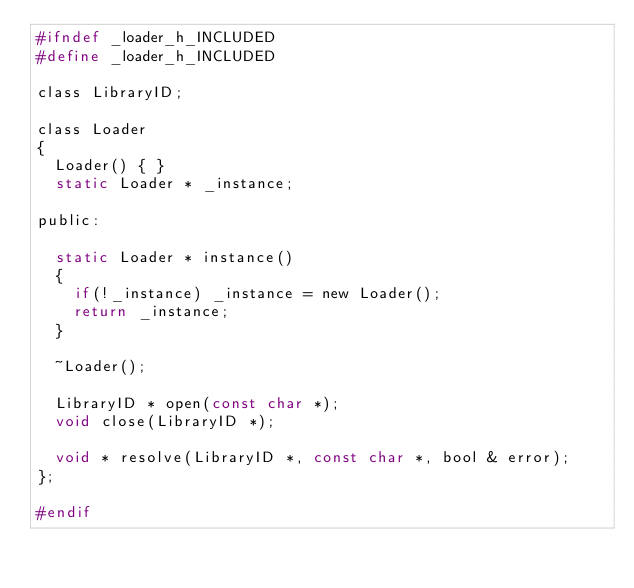Convert code to text. <code><loc_0><loc_0><loc_500><loc_500><_C_>#ifndef _loader_h_INCLUDED
#define _loader_h_INCLUDED

class LibraryID;

class Loader
{
  Loader() { }
  static Loader * _instance;

public:

  static Loader * instance()
  {
    if(!_instance) _instance = new Loader();
    return _instance;
  }

  ~Loader();

  LibraryID * open(const char *);
  void close(LibraryID *);

  void * resolve(LibraryID *, const char *, bool & error);
};

#endif
</code> 